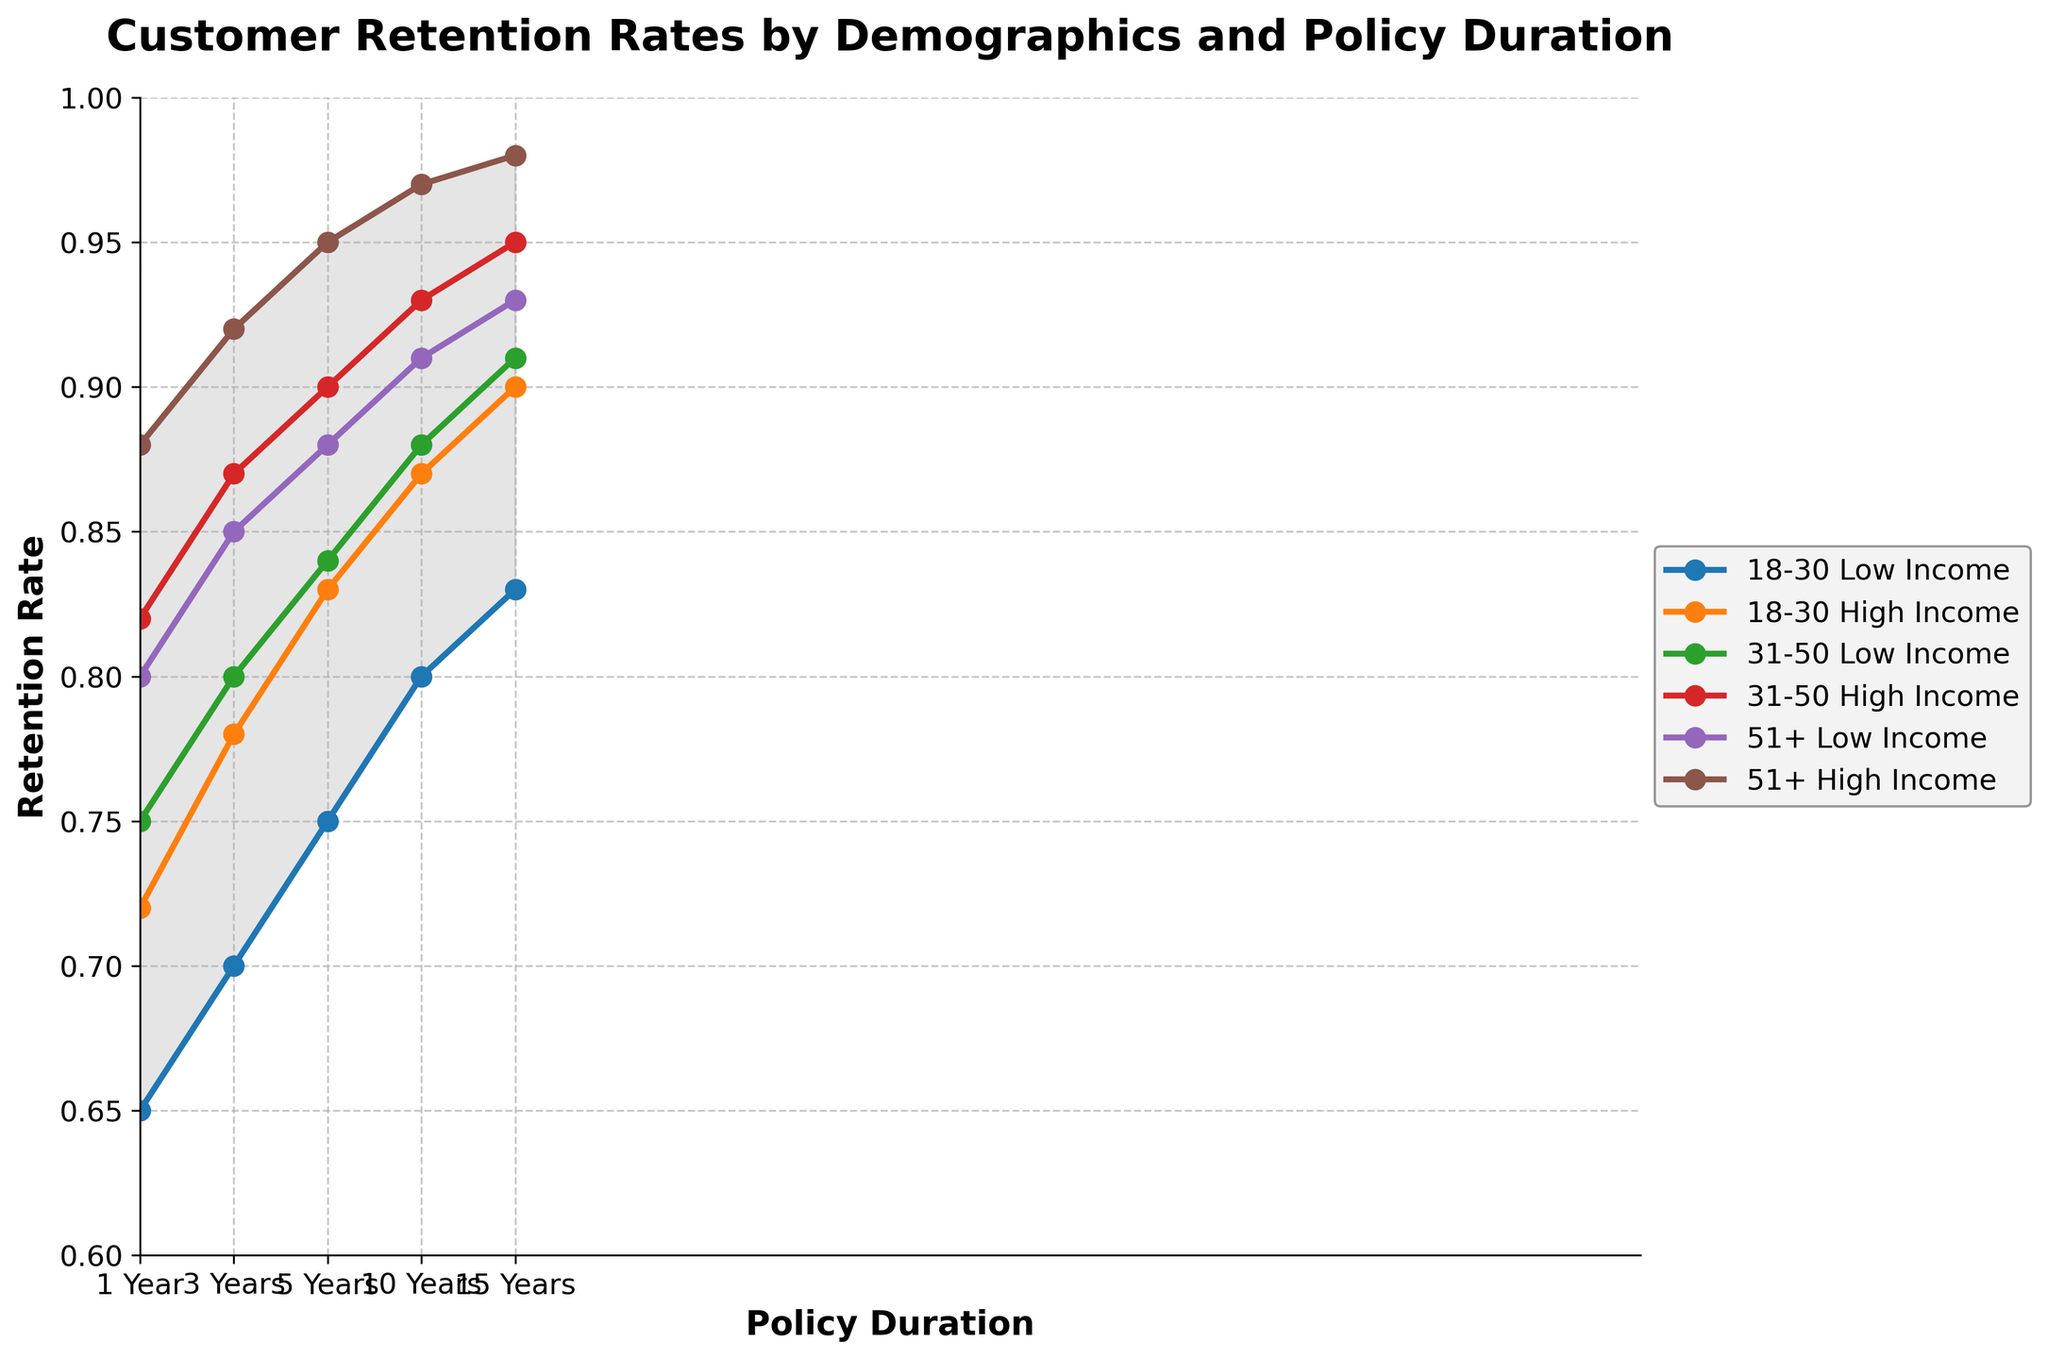What's the title of the figure? The title is prominently displayed at the top of the figure in a larger, bold font.
Answer: Customer Retention Rates by Demographics and Policy Duration What are the labels for the x-axis and y-axis? The x-axis label is located below the x-axis, and the y-axis label is located to the left of the y-axis.
Answer: x-axis: Policy Duration, y-axis: Retention Rate How many demographics and policy durations are included in the figure? The legend indicates six different demographics, and the x-axis shows five policy durations. The demographics are age groups combined with income levels, and the policy durations are listed from 1 Year to 15 Years.
Answer: 6 demographics, 5 policy durations What is the retention rate for the '31-50 High Income' group at 10 Years? Refer to the plot line labeled '31-50 High Income' and find the corresponding y-value at 10 Years on the x-axis.
Answer: 0.93 Which group has the highest retention rate at 5 Years? Look at the plotted lines at the 5 Years mark on the x-axis and find the one with the highest y-value.
Answer: 51+ High Income How does the retention rate for '18-30 Low Income' change from 1 Year to 15 Years? Track the plotted line for '18-30 Low Income' from 1 Year to 15 Years, noting the increase or decrease in the y-values across these points.
Answer: It increases from 0.65 to 0.83 What is the difference in retention rates between '18-30 High Income' and '51+ Low Income' at 3 Years? Find the retention rates for both groups at the 3 Years mark and subtract the smaller rate from the larger rate.
Answer: 0.78 - 0.85 = -0.07 What is the average retention rate for '51+ High Income' across all durations? Sum the retention rates for '51+ High Income' across all durations and divide by the number of durations (5). Calculation: (0.88 + 0.92 + 0.95 + 0.97 + 0.98) / 5
Answer: 0.94 Which group shows the least improvement in retention rate from 1 Year to 15 Years? Calculate the difference between the retention rates at 1 Year and 15 Years for each group, then identify the group with the smallest increase or change.
Answer: 18-30 High Income (0.9 - 0.72 = 0.18) What does the shaded area in the plot represent? The shaded area between the plotted lines shows the range of retention rates across all demographics at each policy duration, indicating the spread or variance among groups.
Answer: Range of retention rates across demographics 